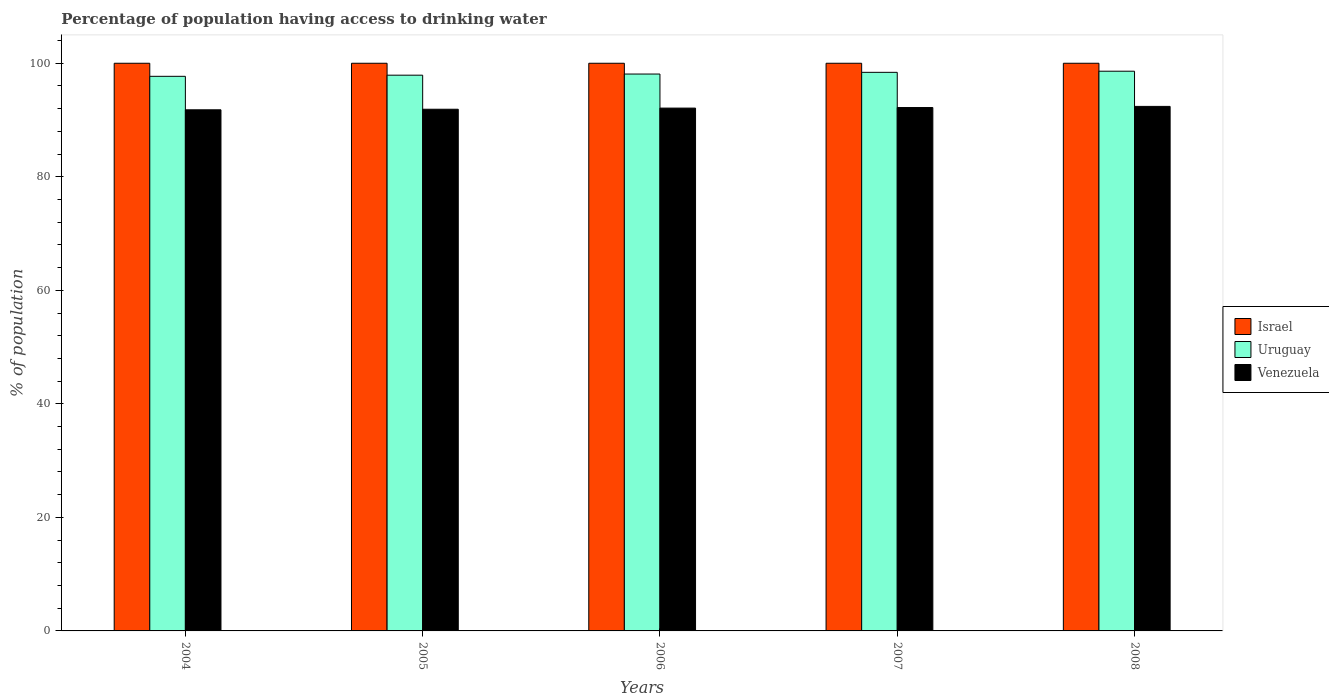How many groups of bars are there?
Provide a short and direct response. 5. Are the number of bars on each tick of the X-axis equal?
Keep it short and to the point. Yes. What is the label of the 2nd group of bars from the left?
Make the answer very short. 2005. What is the percentage of population having access to drinking water in Venezuela in 2007?
Provide a short and direct response. 92.2. Across all years, what is the maximum percentage of population having access to drinking water in Israel?
Offer a very short reply. 100. Across all years, what is the minimum percentage of population having access to drinking water in Uruguay?
Your response must be concise. 97.7. What is the total percentage of population having access to drinking water in Israel in the graph?
Provide a succinct answer. 500. What is the difference between the percentage of population having access to drinking water in Israel in 2005 and that in 2006?
Offer a very short reply. 0. What is the difference between the percentage of population having access to drinking water in Venezuela in 2007 and the percentage of population having access to drinking water in Israel in 2004?
Ensure brevity in your answer.  -7.8. What is the average percentage of population having access to drinking water in Israel per year?
Make the answer very short. 100. In the year 2007, what is the difference between the percentage of population having access to drinking water in Israel and percentage of population having access to drinking water in Venezuela?
Offer a very short reply. 7.8. In how many years, is the percentage of population having access to drinking water in Uruguay greater than 76 %?
Ensure brevity in your answer.  5. What is the ratio of the percentage of population having access to drinking water in Venezuela in 2006 to that in 2007?
Your response must be concise. 1. Is the percentage of population having access to drinking water in Venezuela in 2005 less than that in 2007?
Offer a terse response. Yes. Is the difference between the percentage of population having access to drinking water in Israel in 2006 and 2008 greater than the difference between the percentage of population having access to drinking water in Venezuela in 2006 and 2008?
Your answer should be compact. Yes. What is the difference between the highest and the lowest percentage of population having access to drinking water in Venezuela?
Your answer should be compact. 0.6. In how many years, is the percentage of population having access to drinking water in Venezuela greater than the average percentage of population having access to drinking water in Venezuela taken over all years?
Keep it short and to the point. 3. What does the 2nd bar from the right in 2007 represents?
Provide a short and direct response. Uruguay. What is the difference between two consecutive major ticks on the Y-axis?
Provide a short and direct response. 20. Are the values on the major ticks of Y-axis written in scientific E-notation?
Make the answer very short. No. How many legend labels are there?
Provide a succinct answer. 3. What is the title of the graph?
Make the answer very short. Percentage of population having access to drinking water. Does "United Arab Emirates" appear as one of the legend labels in the graph?
Offer a terse response. No. What is the label or title of the X-axis?
Offer a very short reply. Years. What is the label or title of the Y-axis?
Give a very brief answer. % of population. What is the % of population of Israel in 2004?
Offer a very short reply. 100. What is the % of population of Uruguay in 2004?
Ensure brevity in your answer.  97.7. What is the % of population in Venezuela in 2004?
Offer a very short reply. 91.8. What is the % of population of Israel in 2005?
Make the answer very short. 100. What is the % of population of Uruguay in 2005?
Your response must be concise. 97.9. What is the % of population of Venezuela in 2005?
Your answer should be compact. 91.9. What is the % of population in Uruguay in 2006?
Keep it short and to the point. 98.1. What is the % of population of Venezuela in 2006?
Your response must be concise. 92.1. What is the % of population of Uruguay in 2007?
Your answer should be compact. 98.4. What is the % of population in Venezuela in 2007?
Your answer should be very brief. 92.2. What is the % of population of Uruguay in 2008?
Your answer should be very brief. 98.6. What is the % of population of Venezuela in 2008?
Offer a very short reply. 92.4. Across all years, what is the maximum % of population in Israel?
Provide a short and direct response. 100. Across all years, what is the maximum % of population in Uruguay?
Ensure brevity in your answer.  98.6. Across all years, what is the maximum % of population of Venezuela?
Provide a succinct answer. 92.4. Across all years, what is the minimum % of population in Uruguay?
Keep it short and to the point. 97.7. Across all years, what is the minimum % of population in Venezuela?
Keep it short and to the point. 91.8. What is the total % of population in Israel in the graph?
Provide a short and direct response. 500. What is the total % of population in Uruguay in the graph?
Your answer should be compact. 490.7. What is the total % of population in Venezuela in the graph?
Give a very brief answer. 460.4. What is the difference between the % of population in Venezuela in 2004 and that in 2005?
Keep it short and to the point. -0.1. What is the difference between the % of population of Israel in 2004 and that in 2006?
Provide a short and direct response. 0. What is the difference between the % of population of Uruguay in 2004 and that in 2006?
Provide a succinct answer. -0.4. What is the difference between the % of population of Israel in 2004 and that in 2007?
Offer a terse response. 0. What is the difference between the % of population in Uruguay in 2004 and that in 2007?
Your response must be concise. -0.7. What is the difference between the % of population in Israel in 2004 and that in 2008?
Provide a succinct answer. 0. What is the difference between the % of population in Uruguay in 2004 and that in 2008?
Make the answer very short. -0.9. What is the difference between the % of population of Venezuela in 2004 and that in 2008?
Give a very brief answer. -0.6. What is the difference between the % of population in Uruguay in 2005 and that in 2006?
Your answer should be compact. -0.2. What is the difference between the % of population in Venezuela in 2005 and that in 2006?
Give a very brief answer. -0.2. What is the difference between the % of population in Israel in 2005 and that in 2007?
Your answer should be very brief. 0. What is the difference between the % of population of Uruguay in 2005 and that in 2007?
Offer a terse response. -0.5. What is the difference between the % of population in Venezuela in 2005 and that in 2007?
Ensure brevity in your answer.  -0.3. What is the difference between the % of population of Israel in 2005 and that in 2008?
Your response must be concise. 0. What is the difference between the % of population in Israel in 2006 and that in 2007?
Offer a very short reply. 0. What is the difference between the % of population of Uruguay in 2006 and that in 2007?
Your response must be concise. -0.3. What is the difference between the % of population of Israel in 2006 and that in 2008?
Provide a short and direct response. 0. What is the difference between the % of population of Israel in 2007 and that in 2008?
Your answer should be very brief. 0. What is the difference between the % of population of Uruguay in 2007 and that in 2008?
Your answer should be very brief. -0.2. What is the difference between the % of population of Israel in 2004 and the % of population of Uruguay in 2005?
Make the answer very short. 2.1. What is the difference between the % of population in Israel in 2004 and the % of population in Venezuela in 2006?
Offer a terse response. 7.9. What is the difference between the % of population in Israel in 2004 and the % of population in Uruguay in 2008?
Ensure brevity in your answer.  1.4. What is the difference between the % of population in Israel in 2004 and the % of population in Venezuela in 2008?
Provide a short and direct response. 7.6. What is the difference between the % of population in Israel in 2005 and the % of population in Uruguay in 2006?
Your response must be concise. 1.9. What is the difference between the % of population of Uruguay in 2005 and the % of population of Venezuela in 2006?
Provide a succinct answer. 5.8. What is the difference between the % of population of Uruguay in 2005 and the % of population of Venezuela in 2007?
Offer a terse response. 5.7. What is the difference between the % of population in Uruguay in 2005 and the % of population in Venezuela in 2008?
Keep it short and to the point. 5.5. What is the difference between the % of population in Israel in 2006 and the % of population in Uruguay in 2007?
Keep it short and to the point. 1.6. What is the difference between the % of population of Israel in 2006 and the % of population of Venezuela in 2007?
Keep it short and to the point. 7.8. What is the difference between the % of population in Uruguay in 2006 and the % of population in Venezuela in 2007?
Your response must be concise. 5.9. What is the difference between the % of population of Israel in 2007 and the % of population of Uruguay in 2008?
Your answer should be very brief. 1.4. What is the average % of population of Israel per year?
Ensure brevity in your answer.  100. What is the average % of population in Uruguay per year?
Offer a very short reply. 98.14. What is the average % of population in Venezuela per year?
Make the answer very short. 92.08. In the year 2004, what is the difference between the % of population in Israel and % of population in Venezuela?
Provide a short and direct response. 8.2. In the year 2005, what is the difference between the % of population in Israel and % of population in Venezuela?
Your response must be concise. 8.1. In the year 2005, what is the difference between the % of population of Uruguay and % of population of Venezuela?
Make the answer very short. 6. In the year 2006, what is the difference between the % of population of Israel and % of population of Uruguay?
Keep it short and to the point. 1.9. In the year 2006, what is the difference between the % of population in Israel and % of population in Venezuela?
Your response must be concise. 7.9. In the year 2007, what is the difference between the % of population in Israel and % of population in Uruguay?
Offer a very short reply. 1.6. In the year 2007, what is the difference between the % of population in Uruguay and % of population in Venezuela?
Offer a very short reply. 6.2. In the year 2008, what is the difference between the % of population of Israel and % of population of Uruguay?
Make the answer very short. 1.4. In the year 2008, what is the difference between the % of population of Uruguay and % of population of Venezuela?
Ensure brevity in your answer.  6.2. What is the ratio of the % of population of Israel in 2004 to that in 2005?
Offer a very short reply. 1. What is the ratio of the % of population of Venezuela in 2004 to that in 2005?
Give a very brief answer. 1. What is the ratio of the % of population of Israel in 2004 to that in 2006?
Offer a very short reply. 1. What is the ratio of the % of population of Israel in 2004 to that in 2007?
Provide a succinct answer. 1. What is the ratio of the % of population in Israel in 2004 to that in 2008?
Your answer should be compact. 1. What is the ratio of the % of population of Uruguay in 2004 to that in 2008?
Ensure brevity in your answer.  0.99. What is the ratio of the % of population in Venezuela in 2004 to that in 2008?
Keep it short and to the point. 0.99. What is the ratio of the % of population in Uruguay in 2005 to that in 2006?
Offer a very short reply. 1. What is the ratio of the % of population in Venezuela in 2005 to that in 2006?
Provide a succinct answer. 1. What is the ratio of the % of population of Israel in 2005 to that in 2008?
Keep it short and to the point. 1. What is the ratio of the % of population in Uruguay in 2005 to that in 2008?
Make the answer very short. 0.99. What is the ratio of the % of population of Venezuela in 2005 to that in 2008?
Give a very brief answer. 0.99. What is the ratio of the % of population in Venezuela in 2006 to that in 2007?
Provide a short and direct response. 1. What is the ratio of the % of population of Israel in 2006 to that in 2008?
Offer a terse response. 1. What is the ratio of the % of population of Uruguay in 2007 to that in 2008?
Offer a very short reply. 1. What is the difference between the highest and the second highest % of population in Israel?
Your response must be concise. 0. What is the difference between the highest and the lowest % of population in Israel?
Make the answer very short. 0. What is the difference between the highest and the lowest % of population of Uruguay?
Your answer should be very brief. 0.9. 